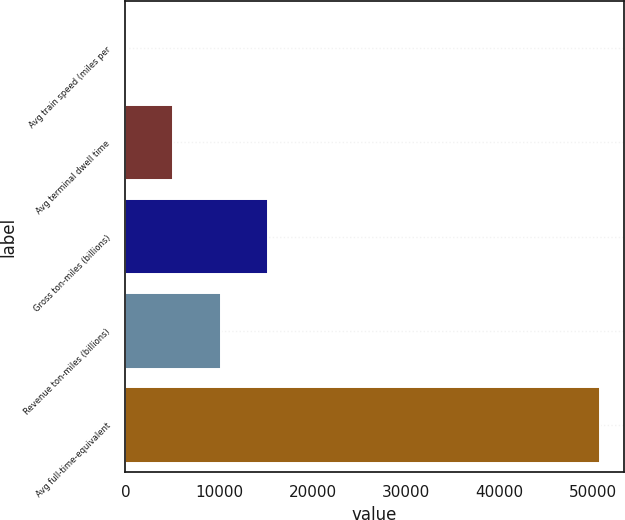<chart> <loc_0><loc_0><loc_500><loc_500><bar_chart><fcel>Avg train speed (miles per<fcel>Avg terminal dwell time<fcel>Gross ton-miles (billions)<fcel>Revenue ton-miles (billions)<fcel>Avg full-time-equivalent<nl><fcel>21.4<fcel>5093.16<fcel>15236.7<fcel>10164.9<fcel>50739<nl></chart> 